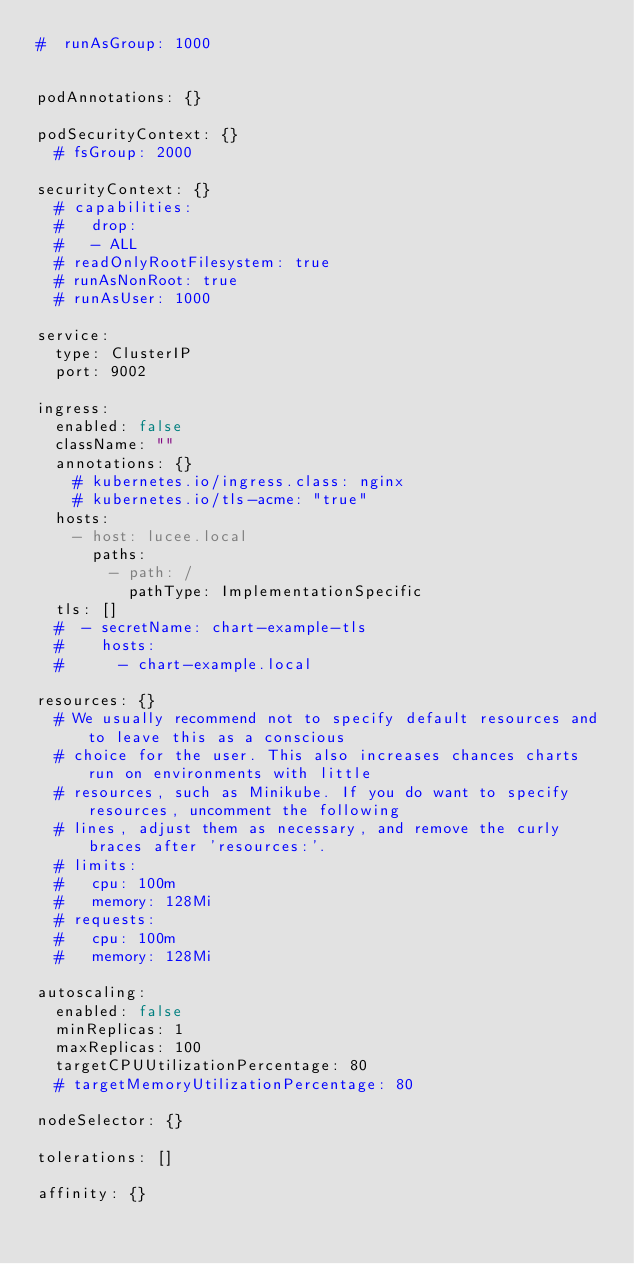<code> <loc_0><loc_0><loc_500><loc_500><_YAML_>#  runAsGroup: 1000


podAnnotations: {}

podSecurityContext: {}
  # fsGroup: 2000

securityContext: {}
  # capabilities:
  #   drop:
  #   - ALL
  # readOnlyRootFilesystem: true
  # runAsNonRoot: true
  # runAsUser: 1000

service:
  type: ClusterIP
  port: 9002

ingress:
  enabled: false
  className: ""
  annotations: {}
    # kubernetes.io/ingress.class: nginx
    # kubernetes.io/tls-acme: "true"
  hosts:
    - host: lucee.local
      paths:
        - path: /
          pathType: ImplementationSpecific
  tls: []
  #  - secretName: chart-example-tls
  #    hosts:
  #      - chart-example.local

resources: {}
  # We usually recommend not to specify default resources and to leave this as a conscious
  # choice for the user. This also increases chances charts run on environments with little
  # resources, such as Minikube. If you do want to specify resources, uncomment the following
  # lines, adjust them as necessary, and remove the curly braces after 'resources:'.
  # limits:
  #   cpu: 100m
  #   memory: 128Mi
  # requests:
  #   cpu: 100m
  #   memory: 128Mi

autoscaling:
  enabled: false
  minReplicas: 1
  maxReplicas: 100
  targetCPUUtilizationPercentage: 80
  # targetMemoryUtilizationPercentage: 80

nodeSelector: {}

tolerations: []

affinity: {}
</code> 